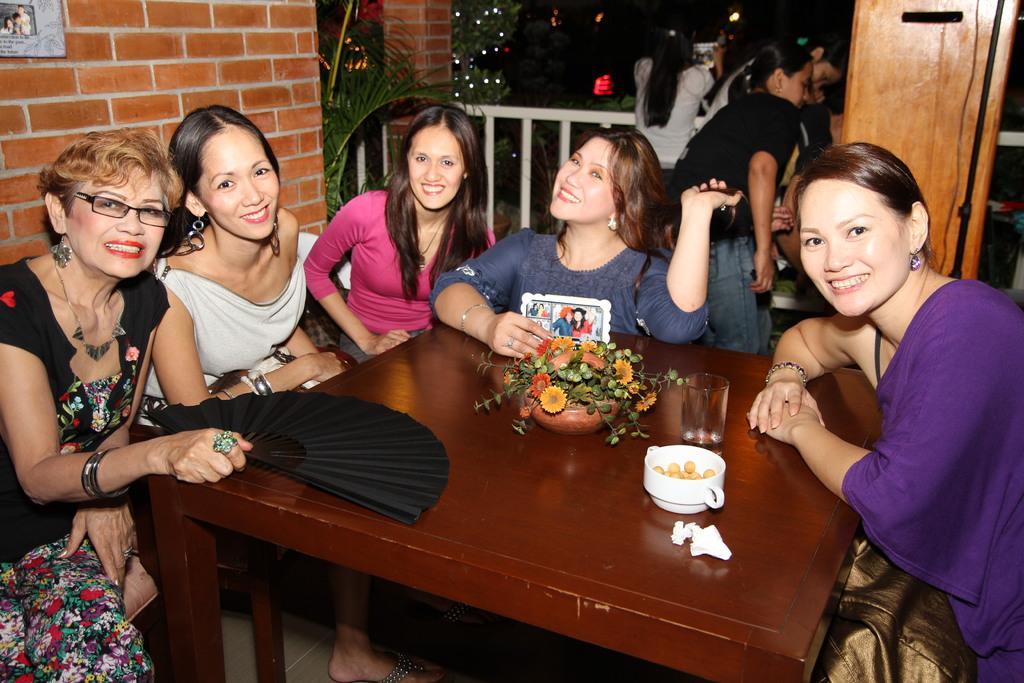In one or two sentences, can you explain what this image depicts? On the table there is flower,glass,bowl around the table woman are sitting in the back there is wall and trees. 